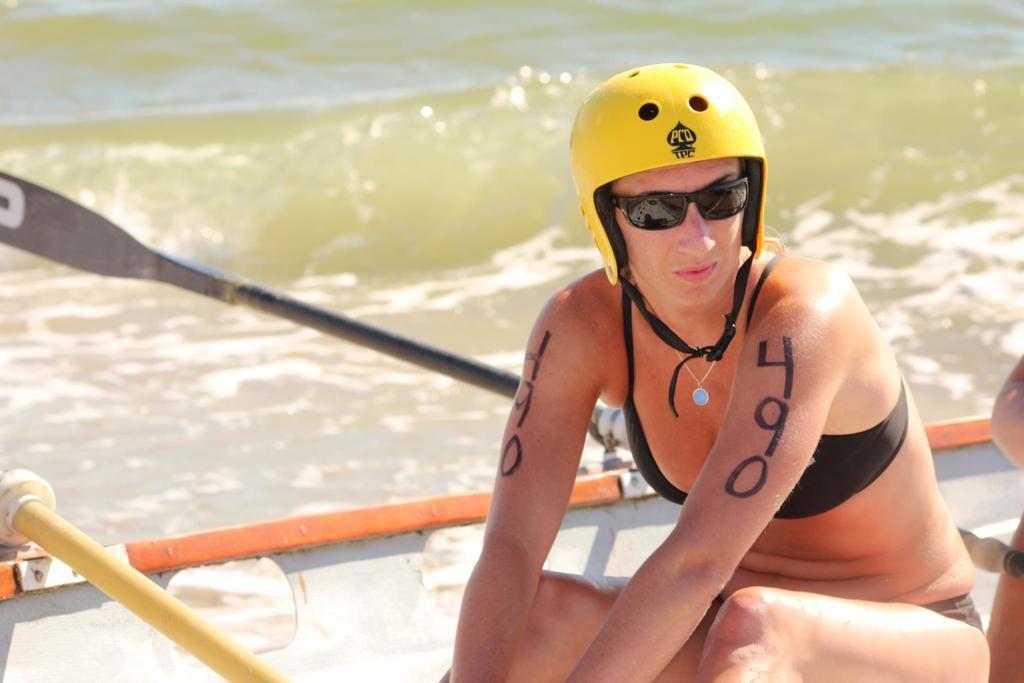Describe this image in one or two sentences. In this image I can see a person sitting in the boat. The person is wearing yellow color helmet and I can also see few paddles in the boat and the boat is on the water. 